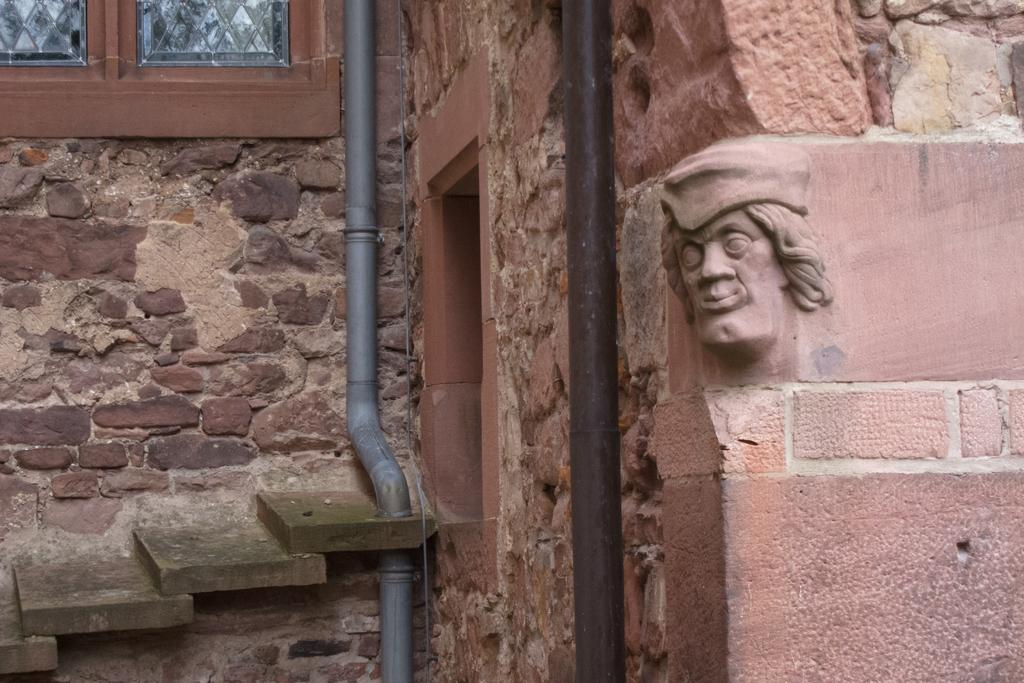What can be seen on the right side of the image? There is a sculpture on the wall on the right side of the image. What is located in the middle of the image? There are pipes in the middle of the image. What architectural feature is on the left side of the image? There is a stair on the left side of the image. What allows natural light into the space in the image? There is a window on the left side of the image. Can you see any feathers or nests in the image? No, there are no feathers or nests present in the image. What type of mountain is visible in the background of the image? There is no mountain visible in the image; it only features a sculpture, pipes, a stair, and a window. 